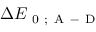Convert formula to latex. <formula><loc_0><loc_0><loc_500><loc_500>\Delta E _ { 0 ; A - D }</formula> 